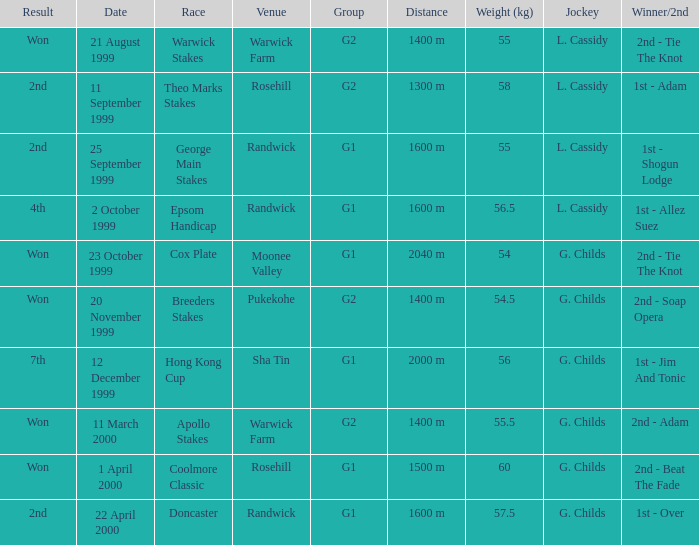5 kilograms. Epsom Handicap. 